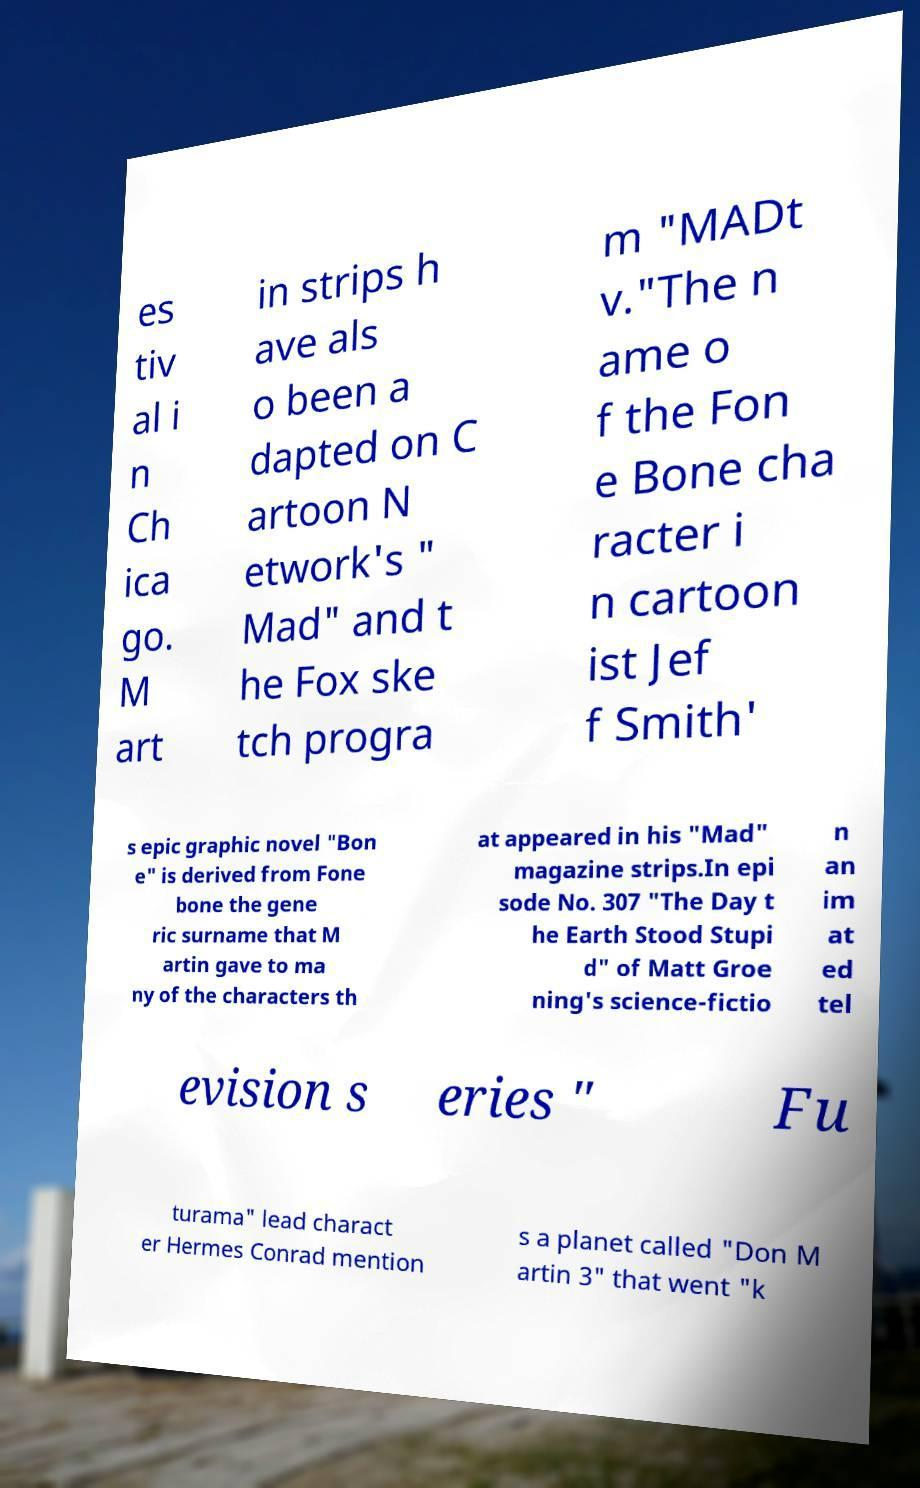Could you assist in decoding the text presented in this image and type it out clearly? es tiv al i n Ch ica go. M art in strips h ave als o been a dapted on C artoon N etwork's " Mad" and t he Fox ske tch progra m "MADt v."The n ame o f the Fon e Bone cha racter i n cartoon ist Jef f Smith' s epic graphic novel "Bon e" is derived from Fone bone the gene ric surname that M artin gave to ma ny of the characters th at appeared in his "Mad" magazine strips.In epi sode No. 307 "The Day t he Earth Stood Stupi d" of Matt Groe ning's science-fictio n an im at ed tel evision s eries " Fu turama" lead charact er Hermes Conrad mention s a planet called "Don M artin 3" that went "k 